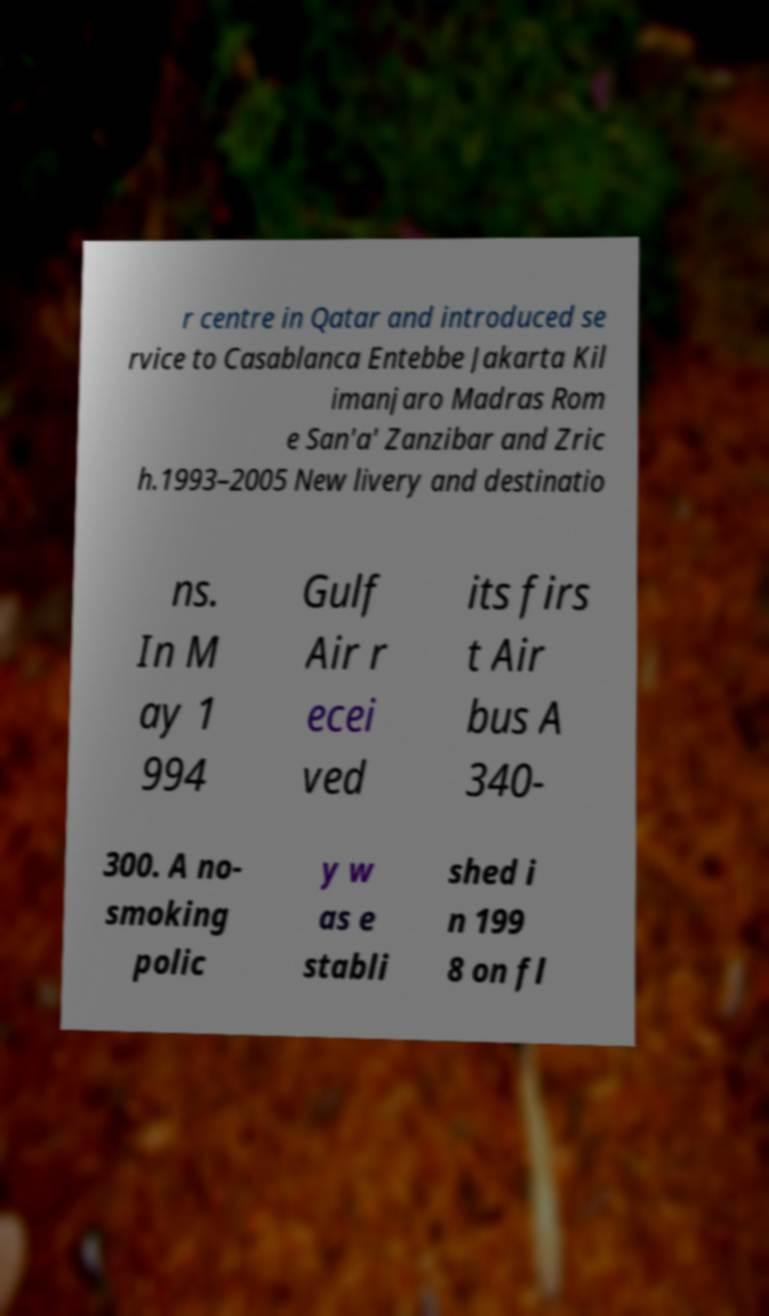Can you read and provide the text displayed in the image?This photo seems to have some interesting text. Can you extract and type it out for me? r centre in Qatar and introduced se rvice to Casablanca Entebbe Jakarta Kil imanjaro Madras Rom e San'a' Zanzibar and Zric h.1993–2005 New livery and destinatio ns. In M ay 1 994 Gulf Air r ecei ved its firs t Air bus A 340- 300. A no- smoking polic y w as e stabli shed i n 199 8 on fl 